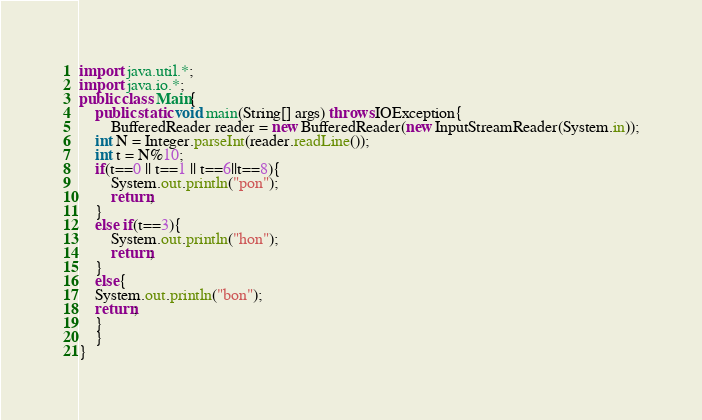Convert code to text. <code><loc_0><loc_0><loc_500><loc_500><_Java_>import java.util.*;
import java.io.*;
public class Main{
	public static void main(String[] args) throws IOException{
		BufferedReader reader = new BufferedReader(new InputStreamReader(System.in));
	int N = Integer.parseInt(reader.readLine());
	int t = N%10;
	if(t==0 || t==1 || t==6||t==8){
		System.out.println("pon");
		return;
	}
	else if(t==3){
		System.out.println("hon");
		return;
	}
	else{
	System.out.println("bon");
	return;
	}
	}
}
</code> 